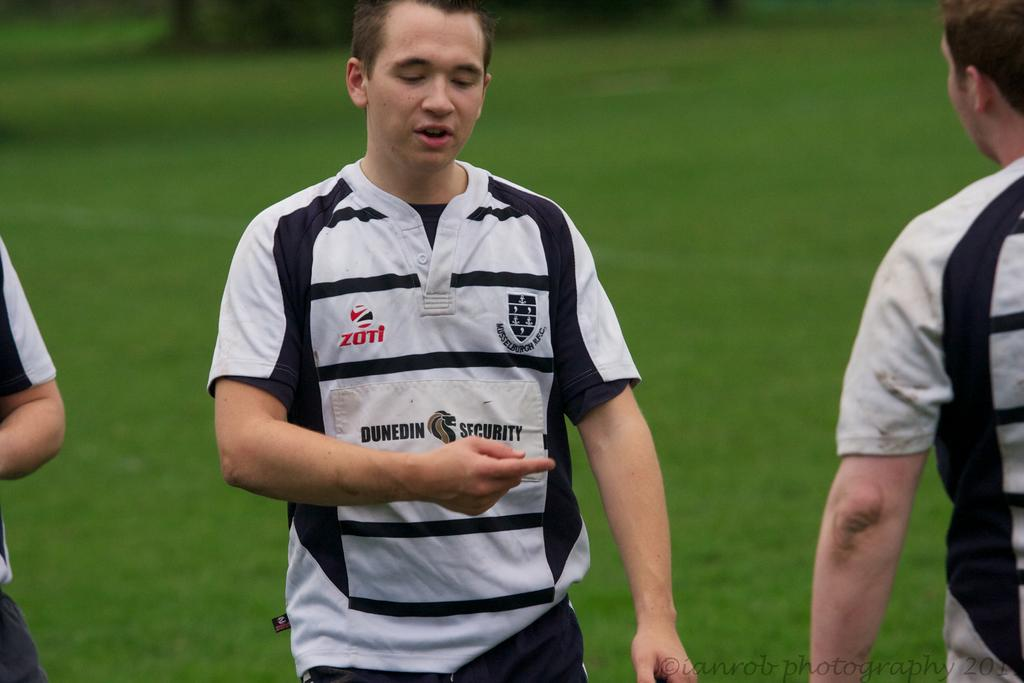<image>
Present a compact description of the photo's key features. Wearing a Dunedin Security shirt, a boy points while talking to another boy. 